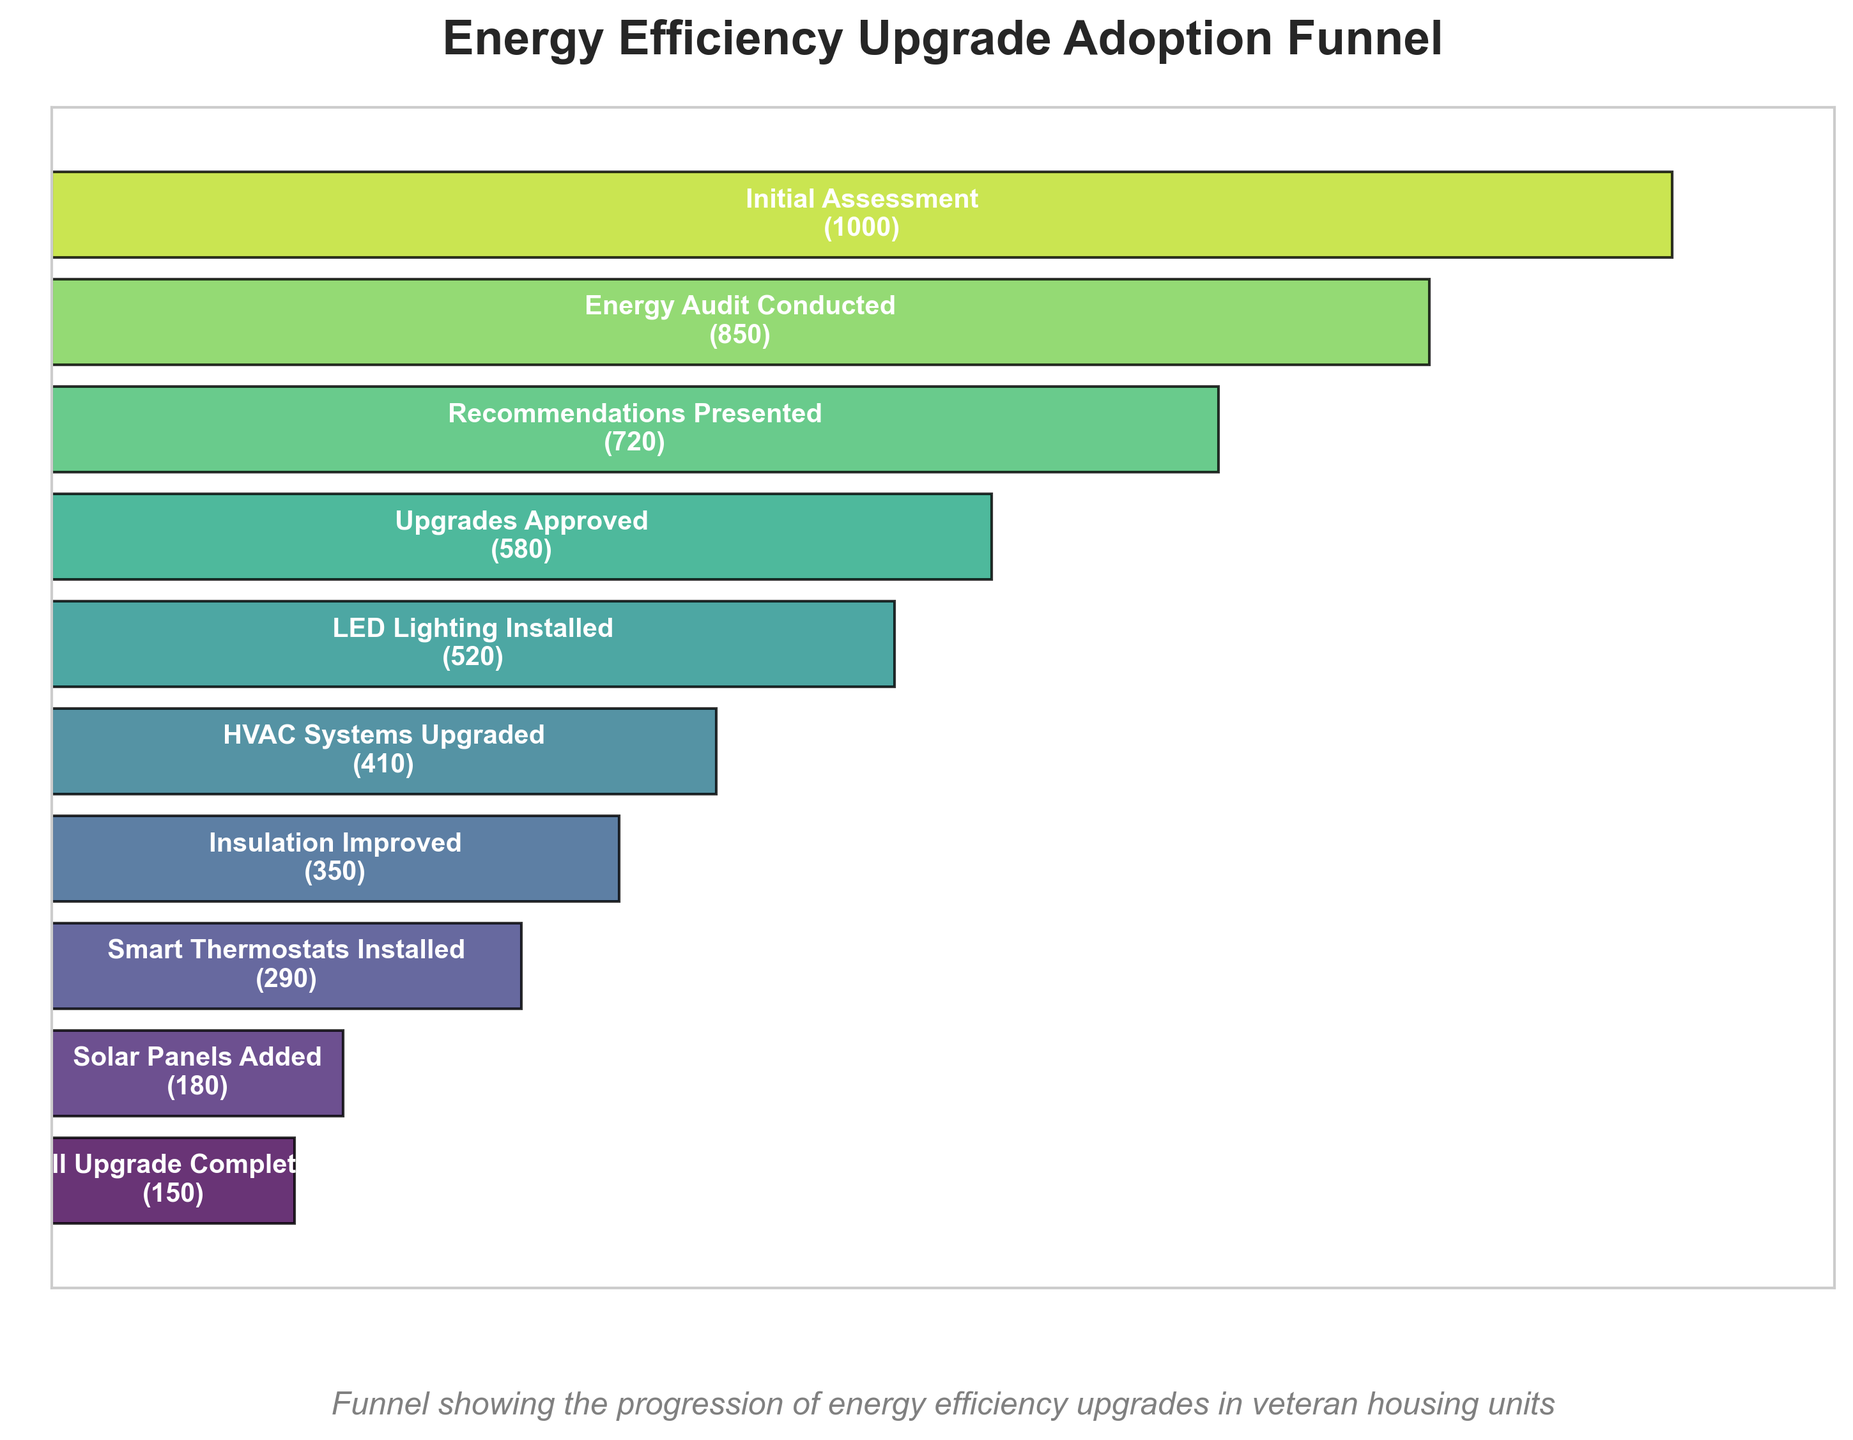What is the title of the funnel chart? The title of the funnel chart is displayed at the top and reads "Energy Efficiency Upgrade Adoption Funnel."
Answer: Energy Efficiency Upgrade Adoption Funnel How many stages are shown in the funnel chart? You can count the number of labeled stages along the vertical axis of the funnel chart.
Answer: 10 Which stage has the highest number of units? The stage "Initial Assessment" at the top of the funnel has the highest number, which is listed as 1000 units.
Answer: Initial Assessment How many units had an energy audit conducted? You can look at the stage labeled "Energy Audit Conducted" and see the number of units.
Answer: 850 What is the range in the number of units between the stage "Energy Audit Conducted" and "Solar Panels Added"? Subtract the number of units for "Solar Panels Added" from "Energy Audit Conducted" (850 - 180).
Answer: 670 Which stage marks the initial significant drop in the number of units compared to the previous stage? The plot shows the first noticeable decrease in the width of the funnel after "Initial Assessment" going to "Energy Audit Conducted" (from 1000 to 850 units).
Answer: Energy Audit Conducted What is the difference in the number of units between "HVAC Systems Upgraded" and "Full Upgrade Completed"? Subtract the number of units in the "Full Upgrade Completed" stage from the "HVAC Systems Upgraded" stage (410 - 150).
Answer: 260 What percentage of the initial assessments resulted in full upgrades? Divide the number of full upgrades (150 units) by the initial assessments (1000 units) and multiply by 100 (150/1000 * 100).
Answer: 15% How many more units had smart thermostats installed compared to those that had solar panels added? Subtract the number of units for "Solar Panels Added" from "Smart Thermostats Installed" (290 - 180).
Answer: 110 At which stage do less than half of the initially assessed units remain in the funnel? Compare each stage's number of units to half of the initial assessments (1000/2 = 500). The first stage below this threshold is "LED Lighting Installed" with 520 units.
Answer: LED Lighting Installed 